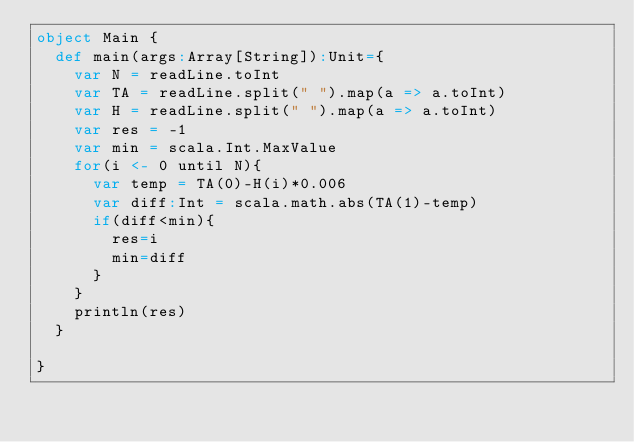<code> <loc_0><loc_0><loc_500><loc_500><_Scala_>object Main {
  def main(args:Array[String]):Unit={
    var N = readLine.toInt
    var TA = readLine.split(" ").map(a => a.toInt)
    var H = readLine.split(" ").map(a => a.toInt)
    var res = -1
    var min = scala.Int.MaxValue
    for(i <- 0 until N){
      var temp = TA(0)-H(i)*0.006
      var diff:Int = scala.math.abs(TA(1)-temp)
      if(diff<min){
        res=i
        min=diff
      }
    }
    println(res)
  }
  
}</code> 